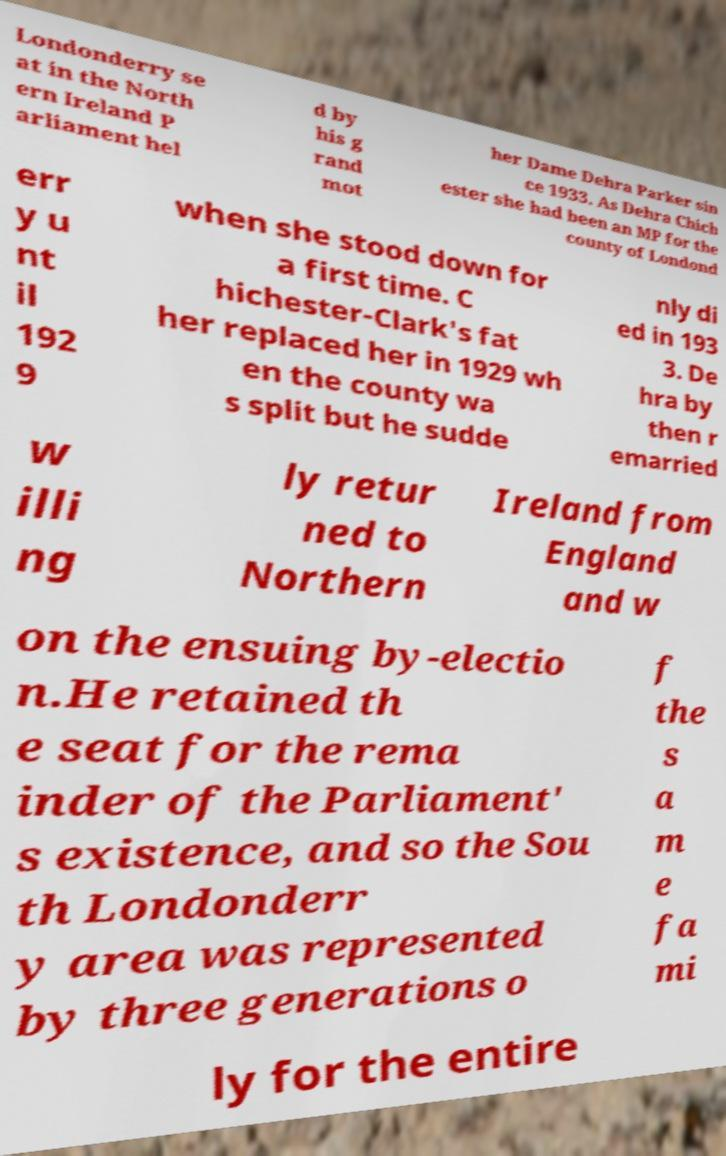Please identify and transcribe the text found in this image. Londonderry se at in the North ern Ireland P arliament hel d by his g rand mot her Dame Dehra Parker sin ce 1933. As Dehra Chich ester she had been an MP for the county of Londond err y u nt il 192 9 when she stood down for a first time. C hichester-Clark's fat her replaced her in 1929 wh en the county wa s split but he sudde nly di ed in 193 3. De hra by then r emarried w illi ng ly retur ned to Northern Ireland from England and w on the ensuing by-electio n.He retained th e seat for the rema inder of the Parliament' s existence, and so the Sou th Londonderr y area was represented by three generations o f the s a m e fa mi ly for the entire 